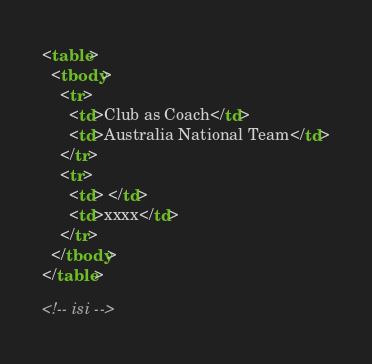Convert code to text. <code><loc_0><loc_0><loc_500><loc_500><_HTML_>
<table>
  <tbody>
    <tr>
      <td>Club as Coach</td>
      <td>Australia National Team</td>
    </tr>
    <tr>
      <td> </td>
      <td>xxxx</td>
    </tr>
  </tbody>
</table>

<!-- isi -->
</code> 